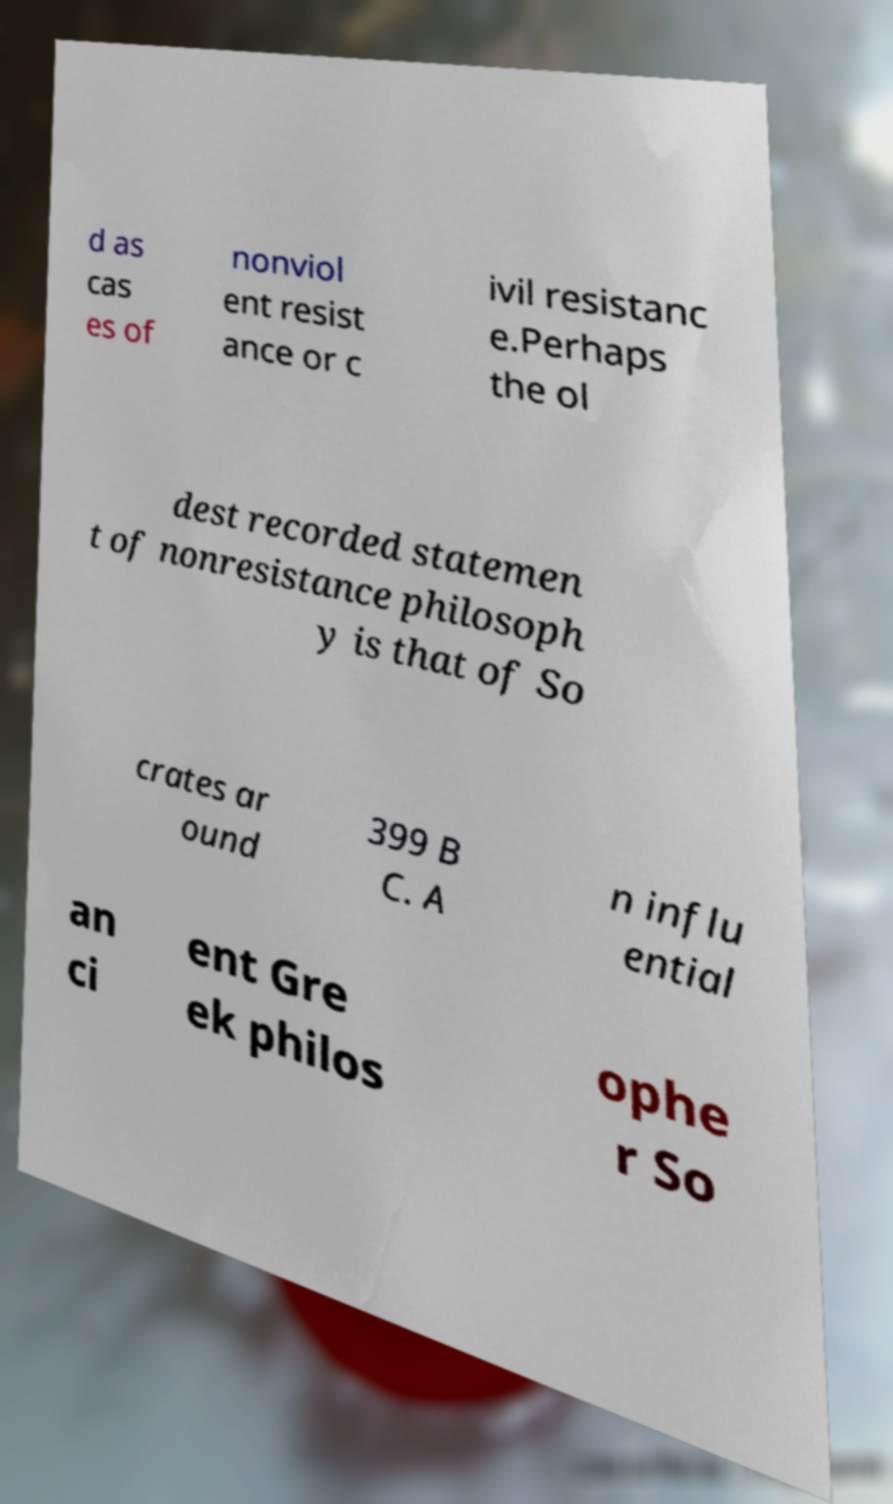I need the written content from this picture converted into text. Can you do that? d as cas es of nonviol ent resist ance or c ivil resistanc e.Perhaps the ol dest recorded statemen t of nonresistance philosoph y is that of So crates ar ound 399 B C. A n influ ential an ci ent Gre ek philos ophe r So 